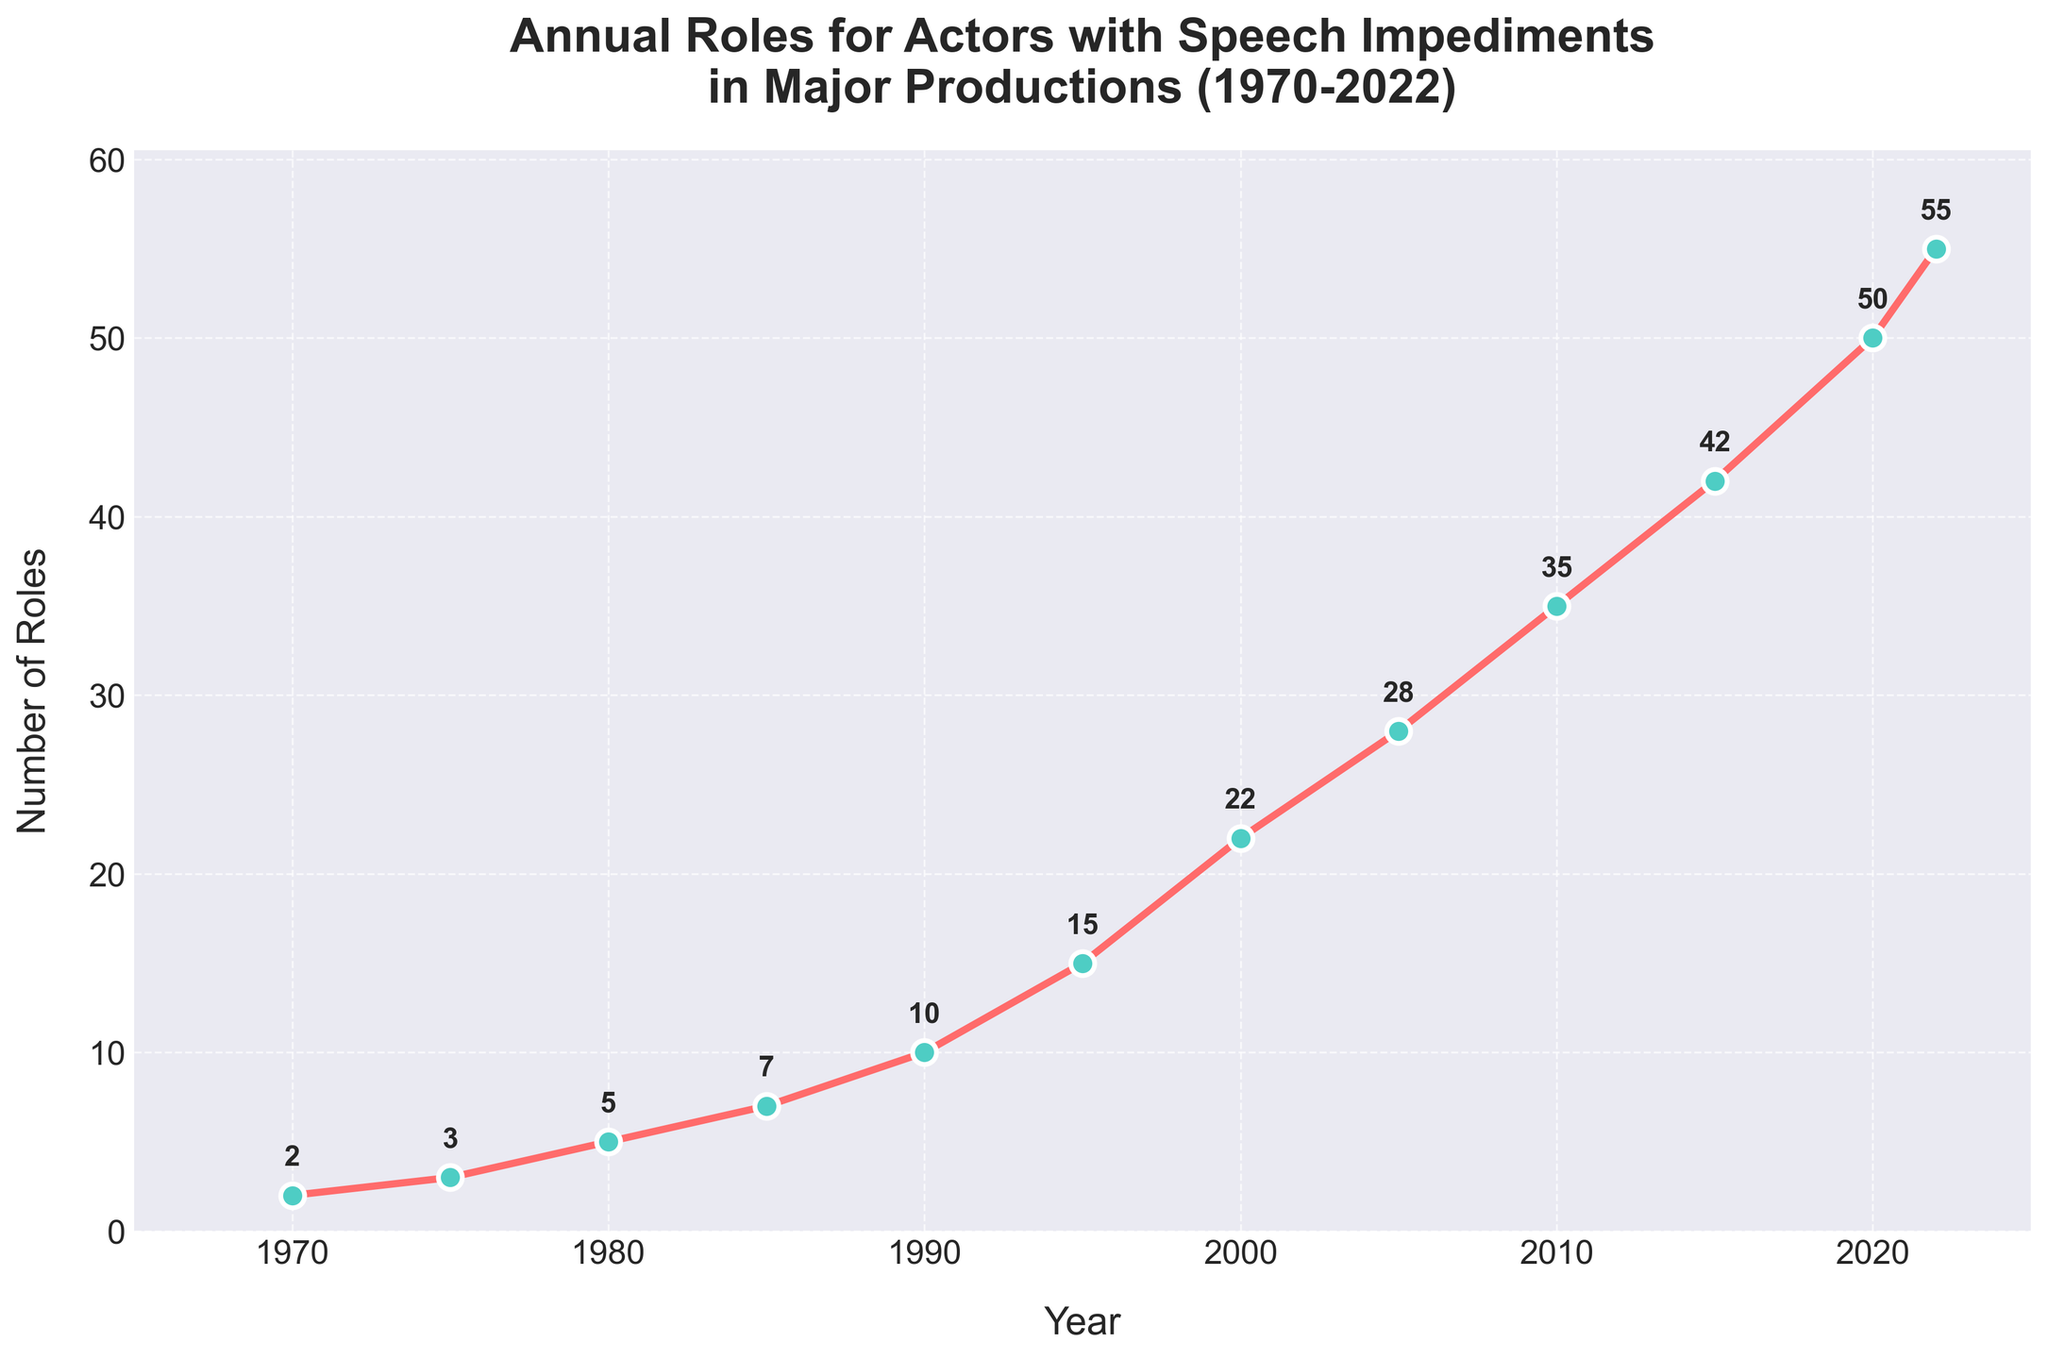What's the total increase in the number of roles from 1970 to 2022? In 1970, the number of roles was 2, and in 2022, it was 55. The increase is computed by subtracting the number of roles in 1970 from the number in 2022, which is 55 - 2.
Answer: 53 In which decade did the number of roles for actors with speech impediments see the highest increase? By examining the graph, the largest increase occurred between 1990 and 2000. The number of roles increased from 10 in 1990 to 22 in 2000, an increase of 12 roles.
Answer: 1990s Which year marked the first significant jump in the number of roles from its prior count? The first significant jump is between 1980 and 1985, where the number of roles increased from 5 to 7.
Answer: 1985 How does the number of roles in 2020 compare to that in 2000? The graph shows 22 roles in 2000 and 50 roles in 2020. To compare, subtract the number in 2000 from the number in 2020, 50 - 22, showing an increase.
Answer: Increased by 28 What is the average annual increase in the number of roles from 1970 to 2022? First, find the total increase, which is 55 - 2 = 53. Then, calculate the number of years between 1970 and 2022, which is 2022 - 1970 = 52 years. Divide the total increase by the number of years, 53 / 52 ≈ 1.02.
Answer: ≈ 1.02 roles per year During which five-year period did the number of roles grow the least? By analyzing the graph, the period from 1970 to 1975 shows the least growth in the number of roles, increasing from 2 to 3.
Answer: 1970-1975 How did the number of roles change between 2015 and 2022? In 2015, the number of roles was 42 and in 2022, it was 55. The change is 55 - 42.
Answer: Increased by 13 Is there any year where the increase in the number of roles was exactly 7 compared to the previous data point? Comparing successive data points: between 2000 and 2005 (22 to 28), the increase is 6; therefore, no exact match for an increase of 7 roles exists.
Answer: No How many roles were added in the last decade (2012-2022)? The number of roles in 2012 and 2022 is not directly provided, so we assume the preceding data point. Between 2010 (35 roles) and 2022 (55 roles), the calculation is 55 - 35 = 20 roles added.
Answer: 20 